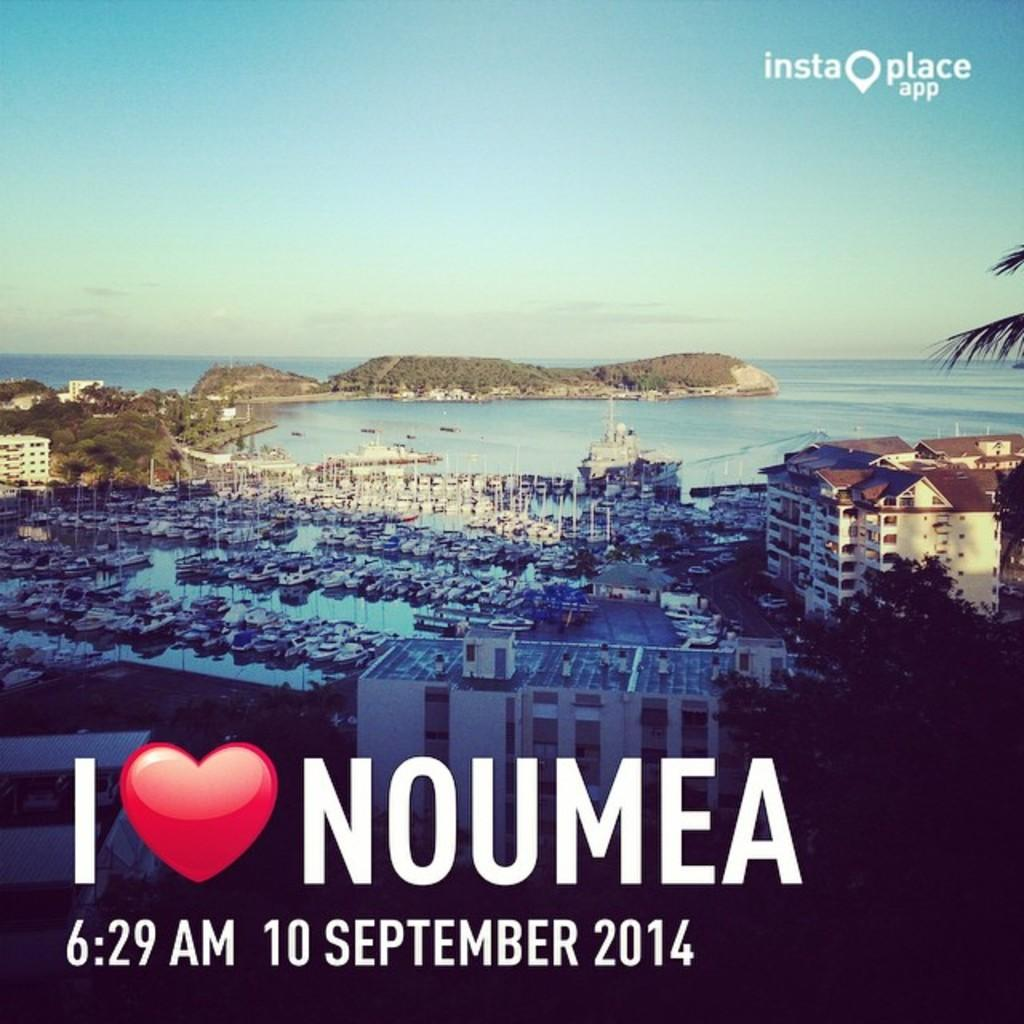<image>
Present a compact description of the photo's key features. A picture of the town  Noumea, and it is by the ocean. 